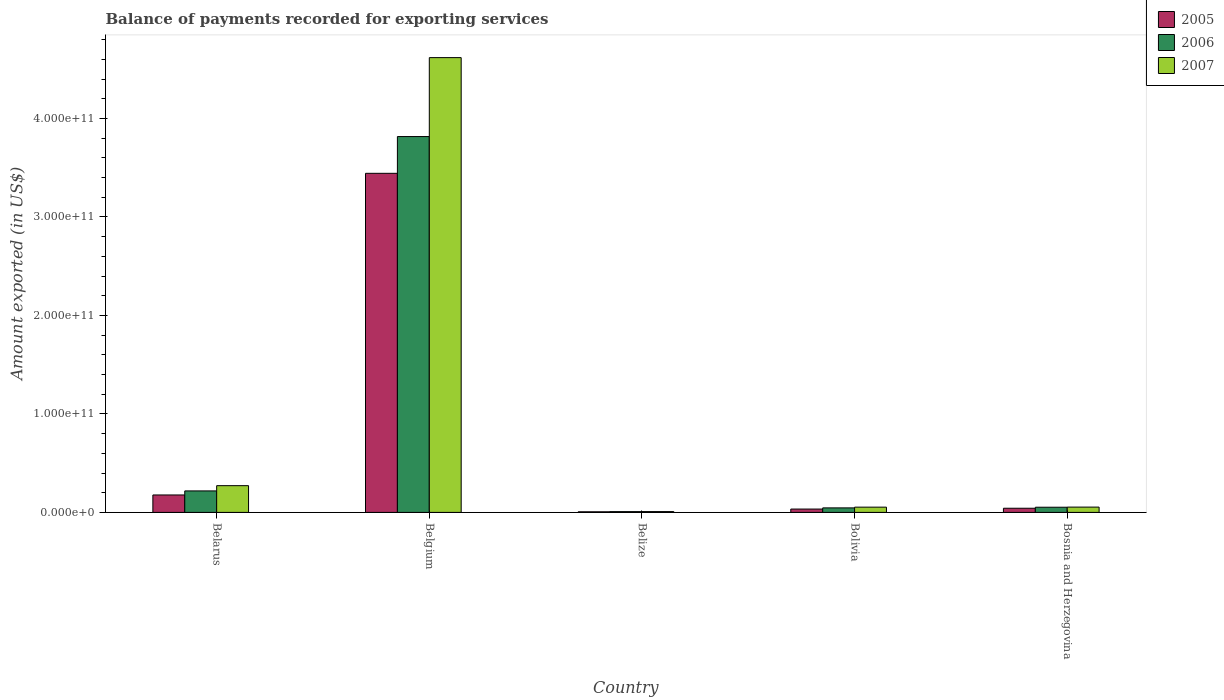How many groups of bars are there?
Provide a succinct answer. 5. Are the number of bars per tick equal to the number of legend labels?
Make the answer very short. Yes. Are the number of bars on each tick of the X-axis equal?
Your answer should be very brief. Yes. How many bars are there on the 3rd tick from the right?
Your response must be concise. 3. What is the label of the 5th group of bars from the left?
Make the answer very short. Bosnia and Herzegovina. What is the amount exported in 2005 in Belgium?
Your answer should be very brief. 3.44e+11. Across all countries, what is the maximum amount exported in 2006?
Provide a succinct answer. 3.82e+11. Across all countries, what is the minimum amount exported in 2007?
Your answer should be very brief. 8.23e+08. In which country was the amount exported in 2005 maximum?
Provide a succinct answer. Belgium. In which country was the amount exported in 2005 minimum?
Provide a succinct answer. Belize. What is the total amount exported in 2007 in the graph?
Your answer should be very brief. 5.01e+11. What is the difference between the amount exported in 2006 in Belgium and that in Bosnia and Herzegovina?
Ensure brevity in your answer.  3.76e+11. What is the difference between the amount exported in 2005 in Bosnia and Herzegovina and the amount exported in 2007 in Belize?
Provide a short and direct response. 3.40e+09. What is the average amount exported in 2005 per country?
Provide a succinct answer. 7.41e+1. What is the difference between the amount exported of/in 2005 and amount exported of/in 2006 in Bolivia?
Your answer should be very brief. -1.18e+09. In how many countries, is the amount exported in 2005 greater than 280000000000 US$?
Your answer should be very brief. 1. What is the ratio of the amount exported in 2006 in Belarus to that in Belgium?
Provide a short and direct response. 0.06. What is the difference between the highest and the second highest amount exported in 2005?
Your response must be concise. 1.35e+1. What is the difference between the highest and the lowest amount exported in 2005?
Ensure brevity in your answer.  3.44e+11. Is the sum of the amount exported in 2007 in Belize and Bolivia greater than the maximum amount exported in 2005 across all countries?
Make the answer very short. No. What does the 3rd bar from the left in Belize represents?
Your response must be concise. 2007. What does the 3rd bar from the right in Belgium represents?
Your response must be concise. 2005. How many bars are there?
Make the answer very short. 15. What is the difference between two consecutive major ticks on the Y-axis?
Provide a succinct answer. 1.00e+11. How many legend labels are there?
Provide a short and direct response. 3. What is the title of the graph?
Your answer should be compact. Balance of payments recorded for exporting services. What is the label or title of the X-axis?
Give a very brief answer. Country. What is the label or title of the Y-axis?
Provide a succinct answer. Amount exported (in US$). What is the Amount exported (in US$) in 2005 in Belarus?
Keep it short and to the point. 1.77e+1. What is the Amount exported (in US$) of 2006 in Belarus?
Keep it short and to the point. 2.18e+1. What is the Amount exported (in US$) of 2007 in Belarus?
Your answer should be compact. 2.71e+1. What is the Amount exported (in US$) of 2005 in Belgium?
Your answer should be compact. 3.44e+11. What is the Amount exported (in US$) of 2006 in Belgium?
Your answer should be compact. 3.82e+11. What is the Amount exported (in US$) in 2007 in Belgium?
Give a very brief answer. 4.62e+11. What is the Amount exported (in US$) in 2005 in Belize?
Your answer should be compact. 6.22e+08. What is the Amount exported (in US$) in 2006 in Belize?
Ensure brevity in your answer.  7.86e+08. What is the Amount exported (in US$) in 2007 in Belize?
Ensure brevity in your answer.  8.23e+08. What is the Amount exported (in US$) in 2005 in Bolivia?
Provide a succinct answer. 3.40e+09. What is the Amount exported (in US$) of 2006 in Bolivia?
Ensure brevity in your answer.  4.58e+09. What is the Amount exported (in US$) of 2007 in Bolivia?
Ensure brevity in your answer.  5.32e+09. What is the Amount exported (in US$) in 2005 in Bosnia and Herzegovina?
Offer a terse response. 4.23e+09. What is the Amount exported (in US$) of 2006 in Bosnia and Herzegovina?
Ensure brevity in your answer.  5.25e+09. What is the Amount exported (in US$) in 2007 in Bosnia and Herzegovina?
Give a very brief answer. 5.38e+09. Across all countries, what is the maximum Amount exported (in US$) in 2005?
Give a very brief answer. 3.44e+11. Across all countries, what is the maximum Amount exported (in US$) in 2006?
Ensure brevity in your answer.  3.82e+11. Across all countries, what is the maximum Amount exported (in US$) of 2007?
Offer a very short reply. 4.62e+11. Across all countries, what is the minimum Amount exported (in US$) of 2005?
Make the answer very short. 6.22e+08. Across all countries, what is the minimum Amount exported (in US$) in 2006?
Your answer should be compact. 7.86e+08. Across all countries, what is the minimum Amount exported (in US$) in 2007?
Your response must be concise. 8.23e+08. What is the total Amount exported (in US$) of 2005 in the graph?
Make the answer very short. 3.70e+11. What is the total Amount exported (in US$) in 2006 in the graph?
Ensure brevity in your answer.  4.14e+11. What is the total Amount exported (in US$) in 2007 in the graph?
Your answer should be compact. 5.01e+11. What is the difference between the Amount exported (in US$) of 2005 in Belarus and that in Belgium?
Your response must be concise. -3.27e+11. What is the difference between the Amount exported (in US$) in 2006 in Belarus and that in Belgium?
Your response must be concise. -3.60e+11. What is the difference between the Amount exported (in US$) of 2007 in Belarus and that in Belgium?
Make the answer very short. -4.35e+11. What is the difference between the Amount exported (in US$) of 2005 in Belarus and that in Belize?
Keep it short and to the point. 1.71e+1. What is the difference between the Amount exported (in US$) in 2006 in Belarus and that in Belize?
Provide a succinct answer. 2.10e+1. What is the difference between the Amount exported (in US$) of 2007 in Belarus and that in Belize?
Provide a succinct answer. 2.63e+1. What is the difference between the Amount exported (in US$) in 2005 in Belarus and that in Bolivia?
Your response must be concise. 1.43e+1. What is the difference between the Amount exported (in US$) of 2006 in Belarus and that in Bolivia?
Keep it short and to the point. 1.72e+1. What is the difference between the Amount exported (in US$) of 2007 in Belarus and that in Bolivia?
Offer a very short reply. 2.18e+1. What is the difference between the Amount exported (in US$) of 2005 in Belarus and that in Bosnia and Herzegovina?
Your response must be concise. 1.35e+1. What is the difference between the Amount exported (in US$) in 2006 in Belarus and that in Bosnia and Herzegovina?
Offer a very short reply. 1.66e+1. What is the difference between the Amount exported (in US$) of 2007 in Belarus and that in Bosnia and Herzegovina?
Provide a short and direct response. 2.18e+1. What is the difference between the Amount exported (in US$) in 2005 in Belgium and that in Belize?
Your answer should be very brief. 3.44e+11. What is the difference between the Amount exported (in US$) in 2006 in Belgium and that in Belize?
Offer a terse response. 3.81e+11. What is the difference between the Amount exported (in US$) of 2007 in Belgium and that in Belize?
Offer a very short reply. 4.61e+11. What is the difference between the Amount exported (in US$) in 2005 in Belgium and that in Bolivia?
Make the answer very short. 3.41e+11. What is the difference between the Amount exported (in US$) in 2006 in Belgium and that in Bolivia?
Provide a short and direct response. 3.77e+11. What is the difference between the Amount exported (in US$) in 2007 in Belgium and that in Bolivia?
Offer a very short reply. 4.57e+11. What is the difference between the Amount exported (in US$) of 2005 in Belgium and that in Bosnia and Herzegovina?
Provide a short and direct response. 3.40e+11. What is the difference between the Amount exported (in US$) of 2006 in Belgium and that in Bosnia and Herzegovina?
Ensure brevity in your answer.  3.76e+11. What is the difference between the Amount exported (in US$) of 2007 in Belgium and that in Bosnia and Herzegovina?
Offer a very short reply. 4.56e+11. What is the difference between the Amount exported (in US$) in 2005 in Belize and that in Bolivia?
Give a very brief answer. -2.78e+09. What is the difference between the Amount exported (in US$) of 2006 in Belize and that in Bolivia?
Offer a very short reply. -3.80e+09. What is the difference between the Amount exported (in US$) in 2007 in Belize and that in Bolivia?
Give a very brief answer. -4.50e+09. What is the difference between the Amount exported (in US$) of 2005 in Belize and that in Bosnia and Herzegovina?
Your response must be concise. -3.60e+09. What is the difference between the Amount exported (in US$) of 2006 in Belize and that in Bosnia and Herzegovina?
Provide a succinct answer. -4.47e+09. What is the difference between the Amount exported (in US$) in 2007 in Belize and that in Bosnia and Herzegovina?
Give a very brief answer. -4.56e+09. What is the difference between the Amount exported (in US$) in 2005 in Bolivia and that in Bosnia and Herzegovina?
Offer a terse response. -8.26e+08. What is the difference between the Amount exported (in US$) of 2006 in Bolivia and that in Bosnia and Herzegovina?
Your answer should be very brief. -6.69e+08. What is the difference between the Amount exported (in US$) of 2007 in Bolivia and that in Bosnia and Herzegovina?
Your response must be concise. -5.49e+07. What is the difference between the Amount exported (in US$) in 2005 in Belarus and the Amount exported (in US$) in 2006 in Belgium?
Your response must be concise. -3.64e+11. What is the difference between the Amount exported (in US$) in 2005 in Belarus and the Amount exported (in US$) in 2007 in Belgium?
Provide a succinct answer. -4.44e+11. What is the difference between the Amount exported (in US$) of 2006 in Belarus and the Amount exported (in US$) of 2007 in Belgium?
Ensure brevity in your answer.  -4.40e+11. What is the difference between the Amount exported (in US$) in 2005 in Belarus and the Amount exported (in US$) in 2006 in Belize?
Offer a very short reply. 1.69e+1. What is the difference between the Amount exported (in US$) of 2005 in Belarus and the Amount exported (in US$) of 2007 in Belize?
Offer a very short reply. 1.69e+1. What is the difference between the Amount exported (in US$) of 2006 in Belarus and the Amount exported (in US$) of 2007 in Belize?
Keep it short and to the point. 2.10e+1. What is the difference between the Amount exported (in US$) of 2005 in Belarus and the Amount exported (in US$) of 2006 in Bolivia?
Ensure brevity in your answer.  1.31e+1. What is the difference between the Amount exported (in US$) in 2005 in Belarus and the Amount exported (in US$) in 2007 in Bolivia?
Provide a succinct answer. 1.24e+1. What is the difference between the Amount exported (in US$) of 2006 in Belarus and the Amount exported (in US$) of 2007 in Bolivia?
Offer a terse response. 1.65e+1. What is the difference between the Amount exported (in US$) in 2005 in Belarus and the Amount exported (in US$) in 2006 in Bosnia and Herzegovina?
Your answer should be very brief. 1.25e+1. What is the difference between the Amount exported (in US$) in 2005 in Belarus and the Amount exported (in US$) in 2007 in Bosnia and Herzegovina?
Give a very brief answer. 1.23e+1. What is the difference between the Amount exported (in US$) in 2006 in Belarus and the Amount exported (in US$) in 2007 in Bosnia and Herzegovina?
Ensure brevity in your answer.  1.64e+1. What is the difference between the Amount exported (in US$) of 2005 in Belgium and the Amount exported (in US$) of 2006 in Belize?
Provide a succinct answer. 3.44e+11. What is the difference between the Amount exported (in US$) in 2005 in Belgium and the Amount exported (in US$) in 2007 in Belize?
Ensure brevity in your answer.  3.44e+11. What is the difference between the Amount exported (in US$) in 2006 in Belgium and the Amount exported (in US$) in 2007 in Belize?
Make the answer very short. 3.81e+11. What is the difference between the Amount exported (in US$) in 2005 in Belgium and the Amount exported (in US$) in 2006 in Bolivia?
Give a very brief answer. 3.40e+11. What is the difference between the Amount exported (in US$) of 2005 in Belgium and the Amount exported (in US$) of 2007 in Bolivia?
Give a very brief answer. 3.39e+11. What is the difference between the Amount exported (in US$) in 2006 in Belgium and the Amount exported (in US$) in 2007 in Bolivia?
Ensure brevity in your answer.  3.76e+11. What is the difference between the Amount exported (in US$) in 2005 in Belgium and the Amount exported (in US$) in 2006 in Bosnia and Herzegovina?
Offer a terse response. 3.39e+11. What is the difference between the Amount exported (in US$) in 2005 in Belgium and the Amount exported (in US$) in 2007 in Bosnia and Herzegovina?
Offer a terse response. 3.39e+11. What is the difference between the Amount exported (in US$) in 2006 in Belgium and the Amount exported (in US$) in 2007 in Bosnia and Herzegovina?
Provide a succinct answer. 3.76e+11. What is the difference between the Amount exported (in US$) of 2005 in Belize and the Amount exported (in US$) of 2006 in Bolivia?
Offer a very short reply. -3.96e+09. What is the difference between the Amount exported (in US$) of 2005 in Belize and the Amount exported (in US$) of 2007 in Bolivia?
Your response must be concise. -4.70e+09. What is the difference between the Amount exported (in US$) in 2006 in Belize and the Amount exported (in US$) in 2007 in Bolivia?
Give a very brief answer. -4.54e+09. What is the difference between the Amount exported (in US$) in 2005 in Belize and the Amount exported (in US$) in 2006 in Bosnia and Herzegovina?
Provide a succinct answer. -4.63e+09. What is the difference between the Amount exported (in US$) of 2005 in Belize and the Amount exported (in US$) of 2007 in Bosnia and Herzegovina?
Your answer should be very brief. -4.76e+09. What is the difference between the Amount exported (in US$) of 2006 in Belize and the Amount exported (in US$) of 2007 in Bosnia and Herzegovina?
Make the answer very short. -4.59e+09. What is the difference between the Amount exported (in US$) in 2005 in Bolivia and the Amount exported (in US$) in 2006 in Bosnia and Herzegovina?
Your response must be concise. -1.85e+09. What is the difference between the Amount exported (in US$) of 2005 in Bolivia and the Amount exported (in US$) of 2007 in Bosnia and Herzegovina?
Offer a terse response. -1.98e+09. What is the difference between the Amount exported (in US$) of 2006 in Bolivia and the Amount exported (in US$) of 2007 in Bosnia and Herzegovina?
Give a very brief answer. -7.95e+08. What is the average Amount exported (in US$) of 2005 per country?
Give a very brief answer. 7.41e+1. What is the average Amount exported (in US$) in 2006 per country?
Provide a succinct answer. 8.28e+1. What is the average Amount exported (in US$) of 2007 per country?
Your response must be concise. 1.00e+11. What is the difference between the Amount exported (in US$) of 2005 and Amount exported (in US$) of 2006 in Belarus?
Provide a short and direct response. -4.11e+09. What is the difference between the Amount exported (in US$) of 2005 and Amount exported (in US$) of 2007 in Belarus?
Provide a short and direct response. -9.44e+09. What is the difference between the Amount exported (in US$) of 2006 and Amount exported (in US$) of 2007 in Belarus?
Provide a short and direct response. -5.33e+09. What is the difference between the Amount exported (in US$) of 2005 and Amount exported (in US$) of 2006 in Belgium?
Ensure brevity in your answer.  -3.73e+1. What is the difference between the Amount exported (in US$) of 2005 and Amount exported (in US$) of 2007 in Belgium?
Provide a short and direct response. -1.18e+11. What is the difference between the Amount exported (in US$) in 2006 and Amount exported (in US$) in 2007 in Belgium?
Provide a succinct answer. -8.02e+1. What is the difference between the Amount exported (in US$) of 2005 and Amount exported (in US$) of 2006 in Belize?
Ensure brevity in your answer.  -1.64e+08. What is the difference between the Amount exported (in US$) of 2005 and Amount exported (in US$) of 2007 in Belize?
Your answer should be very brief. -2.02e+08. What is the difference between the Amount exported (in US$) of 2006 and Amount exported (in US$) of 2007 in Belize?
Keep it short and to the point. -3.73e+07. What is the difference between the Amount exported (in US$) in 2005 and Amount exported (in US$) in 2006 in Bolivia?
Your answer should be compact. -1.18e+09. What is the difference between the Amount exported (in US$) of 2005 and Amount exported (in US$) of 2007 in Bolivia?
Your answer should be compact. -1.92e+09. What is the difference between the Amount exported (in US$) in 2006 and Amount exported (in US$) in 2007 in Bolivia?
Offer a terse response. -7.40e+08. What is the difference between the Amount exported (in US$) in 2005 and Amount exported (in US$) in 2006 in Bosnia and Herzegovina?
Your response must be concise. -1.03e+09. What is the difference between the Amount exported (in US$) in 2005 and Amount exported (in US$) in 2007 in Bosnia and Herzegovina?
Your response must be concise. -1.15e+09. What is the difference between the Amount exported (in US$) of 2006 and Amount exported (in US$) of 2007 in Bosnia and Herzegovina?
Offer a terse response. -1.26e+08. What is the ratio of the Amount exported (in US$) of 2005 in Belarus to that in Belgium?
Your answer should be very brief. 0.05. What is the ratio of the Amount exported (in US$) in 2006 in Belarus to that in Belgium?
Provide a succinct answer. 0.06. What is the ratio of the Amount exported (in US$) in 2007 in Belarus to that in Belgium?
Your answer should be compact. 0.06. What is the ratio of the Amount exported (in US$) in 2005 in Belarus to that in Belize?
Give a very brief answer. 28.47. What is the ratio of the Amount exported (in US$) of 2006 in Belarus to that in Belize?
Provide a succinct answer. 27.75. What is the ratio of the Amount exported (in US$) of 2007 in Belarus to that in Belize?
Offer a terse response. 32.97. What is the ratio of the Amount exported (in US$) of 2005 in Belarus to that in Bolivia?
Your response must be concise. 5.21. What is the ratio of the Amount exported (in US$) of 2006 in Belarus to that in Bolivia?
Offer a very short reply. 4.76. What is the ratio of the Amount exported (in US$) in 2007 in Belarus to that in Bolivia?
Offer a very short reply. 5.1. What is the ratio of the Amount exported (in US$) of 2005 in Belarus to that in Bosnia and Herzegovina?
Offer a terse response. 4.19. What is the ratio of the Amount exported (in US$) in 2006 in Belarus to that in Bosnia and Herzegovina?
Provide a short and direct response. 4.15. What is the ratio of the Amount exported (in US$) of 2007 in Belarus to that in Bosnia and Herzegovina?
Ensure brevity in your answer.  5.05. What is the ratio of the Amount exported (in US$) of 2005 in Belgium to that in Belize?
Ensure brevity in your answer.  553.81. What is the ratio of the Amount exported (in US$) of 2006 in Belgium to that in Belize?
Ensure brevity in your answer.  485.58. What is the ratio of the Amount exported (in US$) of 2007 in Belgium to that in Belize?
Provide a short and direct response. 560.97. What is the ratio of the Amount exported (in US$) of 2005 in Belgium to that in Bolivia?
Offer a terse response. 101.26. What is the ratio of the Amount exported (in US$) in 2006 in Belgium to that in Bolivia?
Your response must be concise. 83.25. What is the ratio of the Amount exported (in US$) of 2007 in Belgium to that in Bolivia?
Your answer should be compact. 86.74. What is the ratio of the Amount exported (in US$) of 2005 in Belgium to that in Bosnia and Herzegovina?
Offer a very short reply. 81.47. What is the ratio of the Amount exported (in US$) of 2006 in Belgium to that in Bosnia and Herzegovina?
Ensure brevity in your answer.  72.65. What is the ratio of the Amount exported (in US$) in 2007 in Belgium to that in Bosnia and Herzegovina?
Keep it short and to the point. 85.86. What is the ratio of the Amount exported (in US$) of 2005 in Belize to that in Bolivia?
Keep it short and to the point. 0.18. What is the ratio of the Amount exported (in US$) of 2006 in Belize to that in Bolivia?
Make the answer very short. 0.17. What is the ratio of the Amount exported (in US$) in 2007 in Belize to that in Bolivia?
Ensure brevity in your answer.  0.15. What is the ratio of the Amount exported (in US$) in 2005 in Belize to that in Bosnia and Herzegovina?
Your response must be concise. 0.15. What is the ratio of the Amount exported (in US$) in 2006 in Belize to that in Bosnia and Herzegovina?
Offer a terse response. 0.15. What is the ratio of the Amount exported (in US$) in 2007 in Belize to that in Bosnia and Herzegovina?
Ensure brevity in your answer.  0.15. What is the ratio of the Amount exported (in US$) of 2005 in Bolivia to that in Bosnia and Herzegovina?
Offer a terse response. 0.8. What is the ratio of the Amount exported (in US$) of 2006 in Bolivia to that in Bosnia and Herzegovina?
Offer a very short reply. 0.87. What is the difference between the highest and the second highest Amount exported (in US$) in 2005?
Make the answer very short. 3.27e+11. What is the difference between the highest and the second highest Amount exported (in US$) in 2006?
Give a very brief answer. 3.60e+11. What is the difference between the highest and the second highest Amount exported (in US$) of 2007?
Your response must be concise. 4.35e+11. What is the difference between the highest and the lowest Amount exported (in US$) in 2005?
Keep it short and to the point. 3.44e+11. What is the difference between the highest and the lowest Amount exported (in US$) of 2006?
Offer a terse response. 3.81e+11. What is the difference between the highest and the lowest Amount exported (in US$) in 2007?
Your response must be concise. 4.61e+11. 